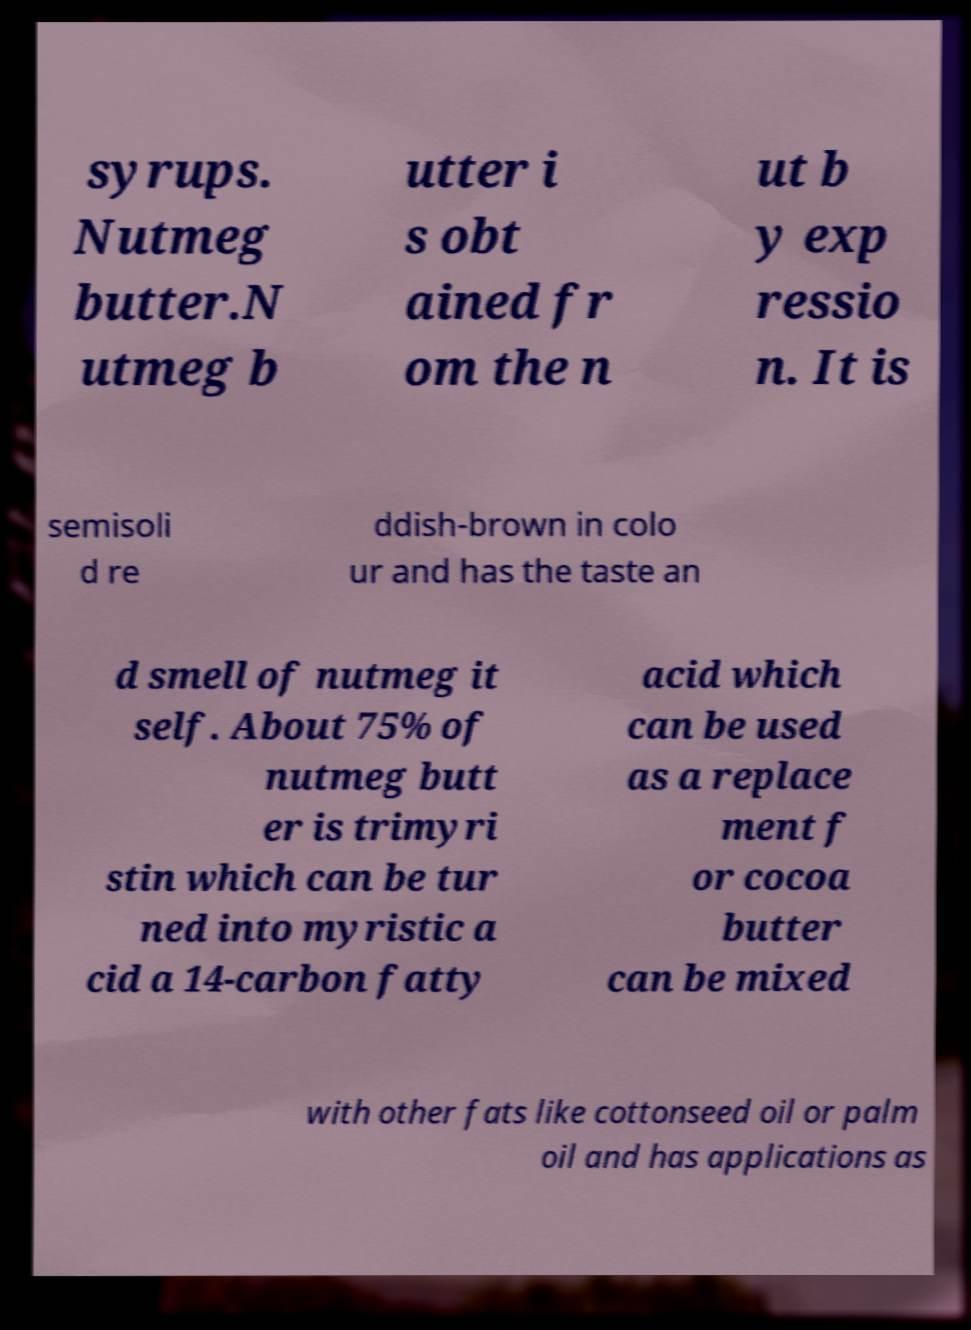Could you assist in decoding the text presented in this image and type it out clearly? syrups. Nutmeg butter.N utmeg b utter i s obt ained fr om the n ut b y exp ressio n. It is semisoli d re ddish-brown in colo ur and has the taste an d smell of nutmeg it self. About 75% of nutmeg butt er is trimyri stin which can be tur ned into myristic a cid a 14-carbon fatty acid which can be used as a replace ment f or cocoa butter can be mixed with other fats like cottonseed oil or palm oil and has applications as 